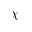Convert formula to latex. <formula><loc_0><loc_0><loc_500><loc_500>\chi</formula> 